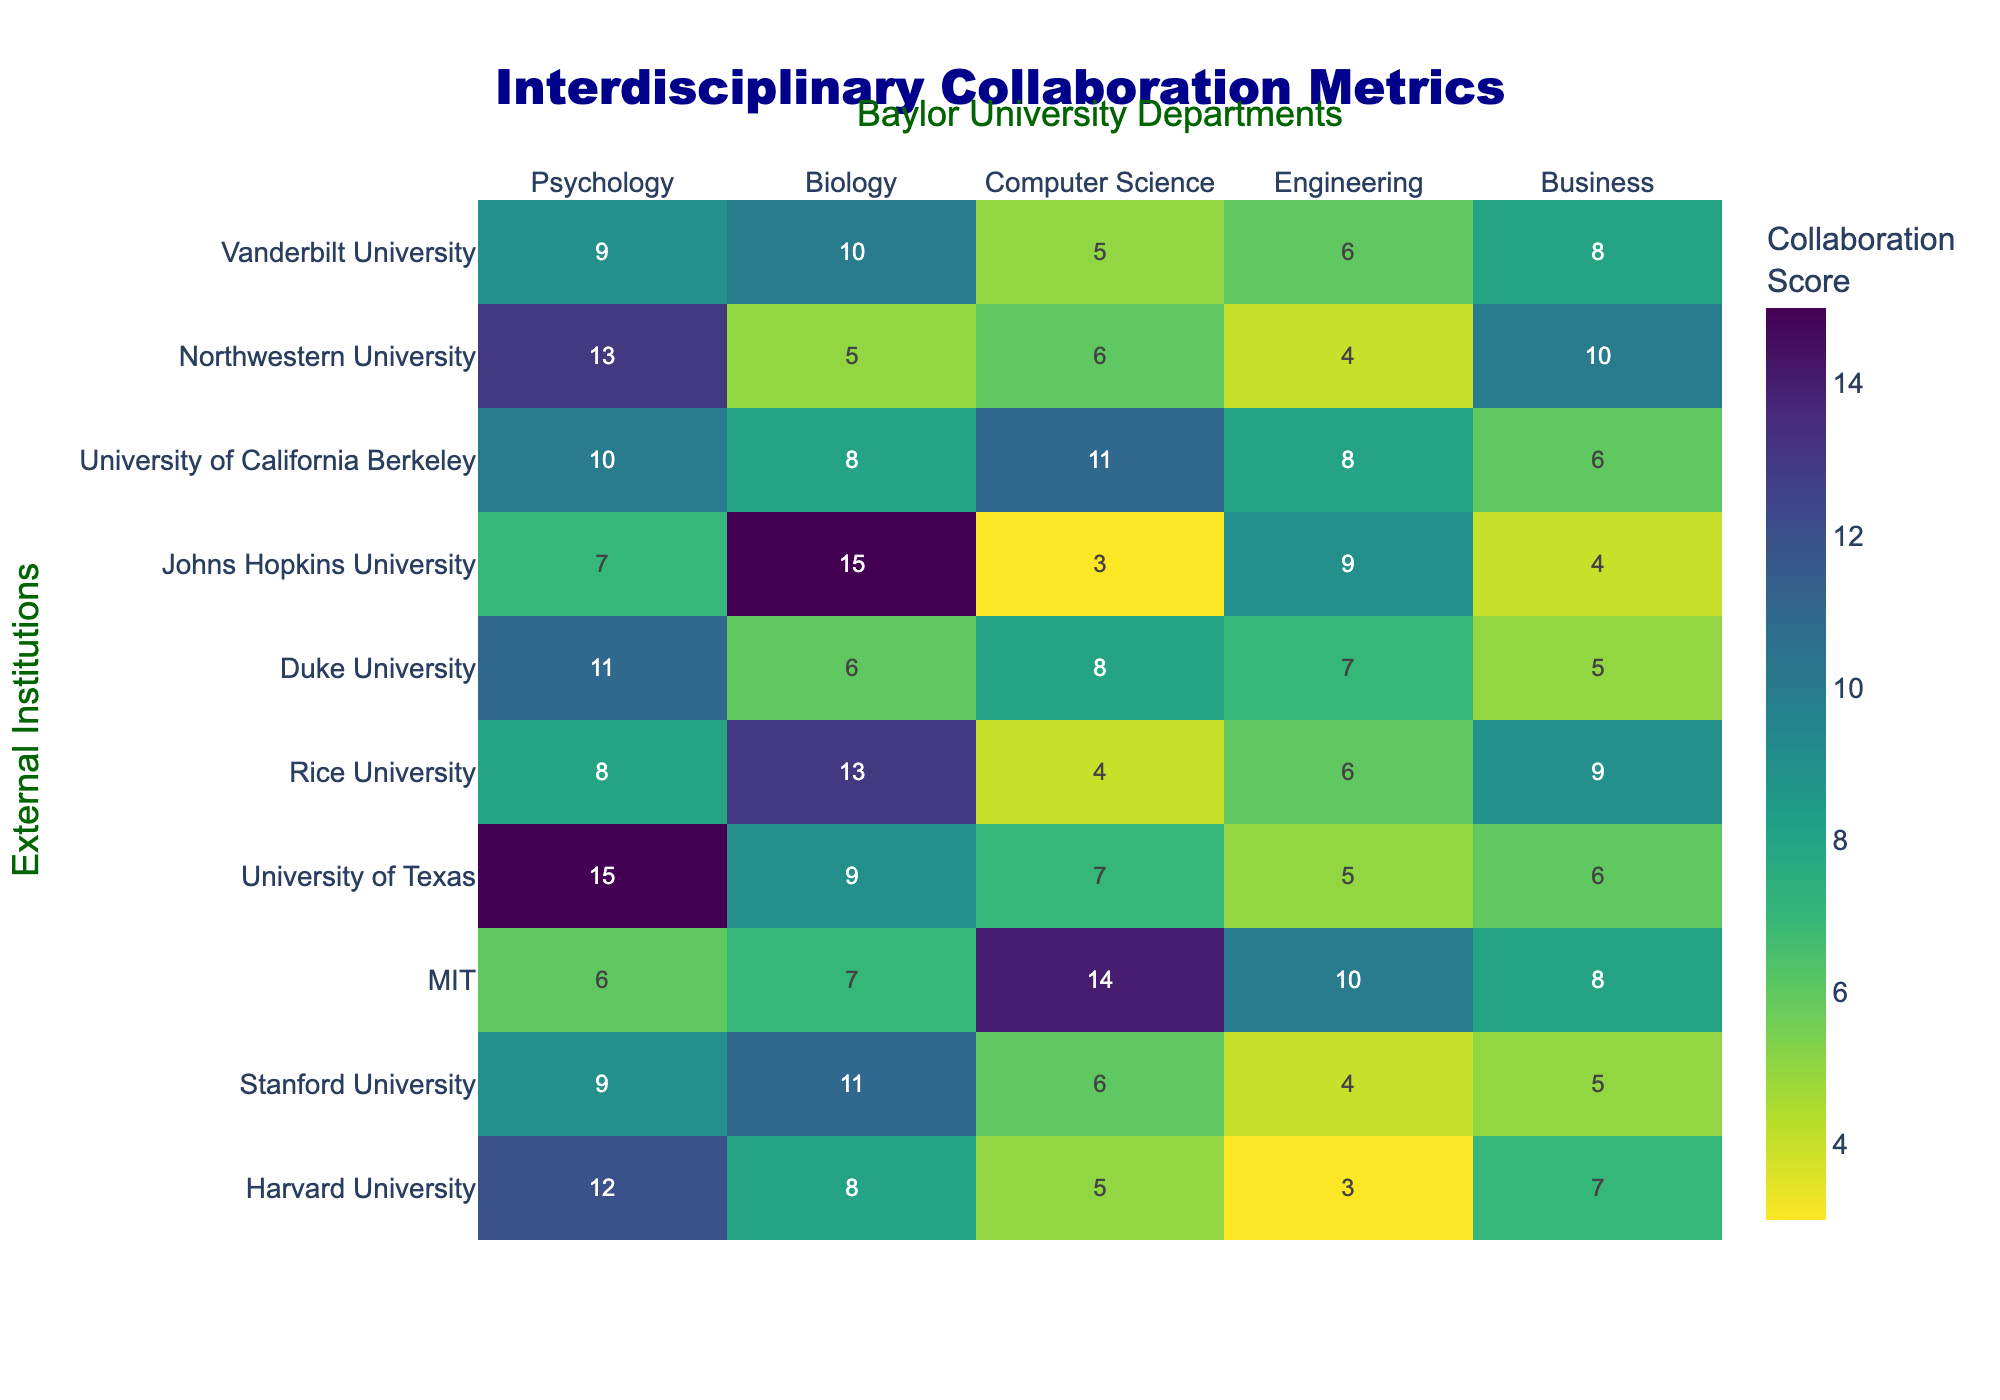What is the highest collaboration score for the Psychology department? By looking at the table, the highest value in the Psychology column is 15 from the University of Texas.
Answer: 15 Which university has the lowest collaboration score with the Engineering department? The lowest value in the Engineering column is 3, which belongs to Harvard University.
Answer: Harvard University What is the total collaboration score for Biology with all external institutions? To find the total for Biology, I sum the values in the Biology column: 8 + 11 + 7 + 9 + 13 + 6 + 15 + 8 + 5 + 10 = 88.
Answer: 88 Is it true that MIT has a higher collaboration score with Computer Science than with Engineering? The score for Computer Science at MIT is 14, while for Engineering it is 10. Therefore, it is true.
Answer: Yes Which external institution has the highest collaboration score overall, considering all departments? By reviewing the entire table, the highest score is 15 (from University of Texas in the Psychology department). Since this is the highest across all departments, it shows University of Texas has the highest overall collaboration score.
Answer: University of Texas What is the average collaboration score for the Computer Science department with external institutions? The values for Computer Science are 5, 6, 14, 7, 4, 8, 3, 11, 6, 5. The total is 69. Divide that by 10 (the number of institutions) gives 69/10 = 6.9.
Answer: 6.9 Which department collaborates the most with Harvard University? Looking at the Harvard University row, the highest score is 12 in the Psychology department, indicating the most collaboration is there.
Answer: Psychology Compare the collaboration scores of Business and Psychology at Johns Hopkins University. At Johns Hopkins University, the scores are 4 for Business and 7 for Psychology. Thus, Psychology has a higher score than Business.
Answer: Psychology What is the difference between the highest and lowest collaboration scores for the Biology department? The highest score for Biology is 15 (Johns Hopkins University), and the lowest is 6 (Northwestern University). The difference is 15 - 6 = 9.
Answer: 9 How many external institutions have a collaboration score of 10 or more with the Business department? Reviewing the Business column, we find scores of 10 and greater from Northwestern University (10) and Rice University (9). So, only 1 institution has 10 or more.
Answer: 1 